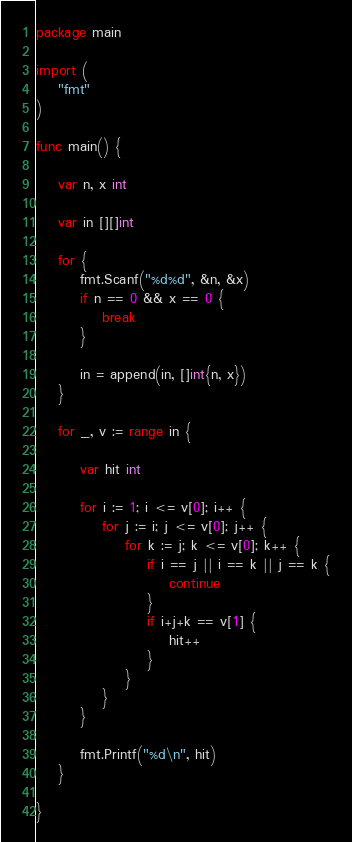<code> <loc_0><loc_0><loc_500><loc_500><_Go_>package main

import (
	"fmt"
)

func main() {

	var n, x int

	var in [][]int

	for {
		fmt.Scanf("%d%d", &n, &x)
		if n == 0 && x == 0 {
			break
		}

		in = append(in, []int{n, x})
	}

	for _, v := range in {

		var hit int

		for i := 1; i <= v[0]; i++ {
			for j := i; j <= v[0]; j++ {
				for k := j; k <= v[0]; k++ {
					if i == j || i == k || j == k {
						continue
					}
					if i+j+k == v[1] {
						hit++
					}
				}
			}
		}

		fmt.Printf("%d\n", hit)
	}

}

</code> 